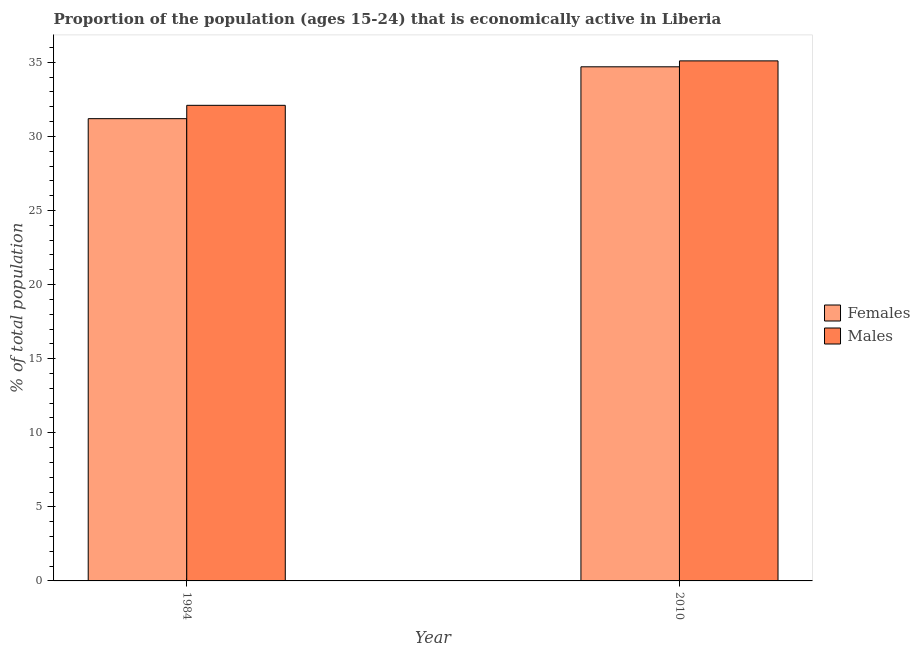How many different coloured bars are there?
Your answer should be very brief. 2. How many groups of bars are there?
Ensure brevity in your answer.  2. In how many cases, is the number of bars for a given year not equal to the number of legend labels?
Provide a short and direct response. 0. What is the percentage of economically active female population in 2010?
Keep it short and to the point. 34.7. Across all years, what is the maximum percentage of economically active female population?
Keep it short and to the point. 34.7. Across all years, what is the minimum percentage of economically active male population?
Make the answer very short. 32.1. In which year was the percentage of economically active female population minimum?
Provide a succinct answer. 1984. What is the total percentage of economically active male population in the graph?
Provide a short and direct response. 67.2. What is the difference between the percentage of economically active female population in 1984 and the percentage of economically active male population in 2010?
Keep it short and to the point. -3.5. What is the average percentage of economically active female population per year?
Provide a short and direct response. 32.95. In how many years, is the percentage of economically active male population greater than 29 %?
Keep it short and to the point. 2. What is the ratio of the percentage of economically active female population in 1984 to that in 2010?
Offer a very short reply. 0.9. In how many years, is the percentage of economically active male population greater than the average percentage of economically active male population taken over all years?
Provide a short and direct response. 1. What does the 1st bar from the left in 2010 represents?
Offer a very short reply. Females. What does the 1st bar from the right in 2010 represents?
Offer a very short reply. Males. How many years are there in the graph?
Your answer should be very brief. 2. Are the values on the major ticks of Y-axis written in scientific E-notation?
Ensure brevity in your answer.  No. Where does the legend appear in the graph?
Keep it short and to the point. Center right. How many legend labels are there?
Your answer should be compact. 2. What is the title of the graph?
Your response must be concise. Proportion of the population (ages 15-24) that is economically active in Liberia. Does "Import" appear as one of the legend labels in the graph?
Make the answer very short. No. What is the label or title of the Y-axis?
Your response must be concise. % of total population. What is the % of total population of Females in 1984?
Provide a succinct answer. 31.2. What is the % of total population of Males in 1984?
Provide a succinct answer. 32.1. What is the % of total population in Females in 2010?
Your answer should be compact. 34.7. What is the % of total population in Males in 2010?
Offer a very short reply. 35.1. Across all years, what is the maximum % of total population of Females?
Make the answer very short. 34.7. Across all years, what is the maximum % of total population of Males?
Ensure brevity in your answer.  35.1. Across all years, what is the minimum % of total population of Females?
Your response must be concise. 31.2. Across all years, what is the minimum % of total population in Males?
Offer a terse response. 32.1. What is the total % of total population in Females in the graph?
Give a very brief answer. 65.9. What is the total % of total population of Males in the graph?
Make the answer very short. 67.2. What is the difference between the % of total population of Males in 1984 and that in 2010?
Ensure brevity in your answer.  -3. What is the average % of total population in Females per year?
Offer a very short reply. 32.95. What is the average % of total population in Males per year?
Your answer should be very brief. 33.6. What is the ratio of the % of total population in Females in 1984 to that in 2010?
Give a very brief answer. 0.9. What is the ratio of the % of total population of Males in 1984 to that in 2010?
Ensure brevity in your answer.  0.91. 